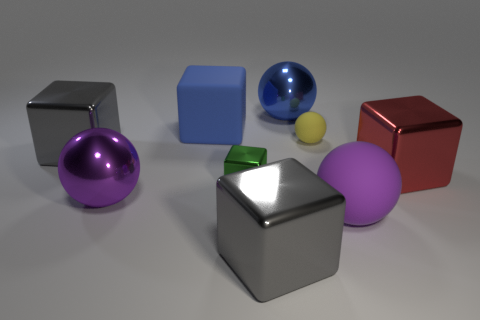Are there an equal number of blue cubes that are on the right side of the big red thing and green shiny blocks that are to the right of the large matte sphere?
Make the answer very short. Yes. Does the matte block have the same size as the metal block on the right side of the small yellow rubber sphere?
Your response must be concise. Yes. There is a big metal object behind the yellow sphere; is there a large blue block on the right side of it?
Your answer should be very brief. No. Are there any other metallic objects of the same shape as the large purple shiny object?
Provide a short and direct response. Yes. There is a purple thing right of the purple object to the left of the blue ball; what number of gray shiny blocks are in front of it?
Provide a short and direct response. 1. There is a tiny metallic block; is its color the same as the big cube on the right side of the purple rubber thing?
Your answer should be compact. No. How many objects are either big metallic balls behind the big red metallic object or things that are right of the purple metal ball?
Make the answer very short. 7. Are there more big objects to the right of the tiny green shiny cube than matte blocks to the right of the blue ball?
Make the answer very short. Yes. What material is the gray object that is in front of the block to the right of the yellow matte sphere that is behind the big matte ball made of?
Offer a very short reply. Metal. Do the big rubber thing that is on the left side of the yellow ball and the matte thing right of the tiny yellow rubber sphere have the same shape?
Your answer should be very brief. No. 